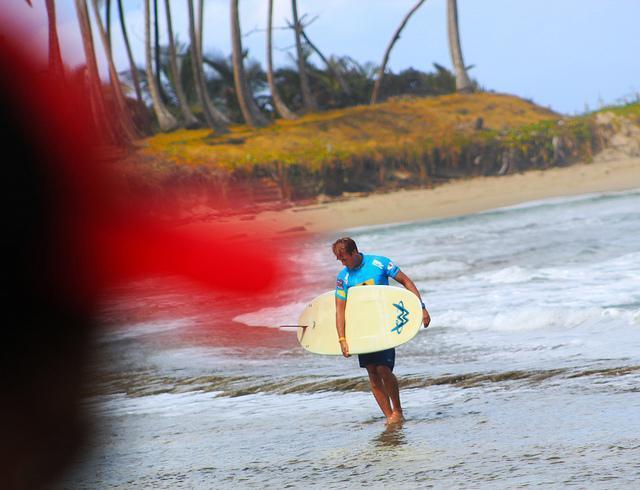How many people can you see?
Give a very brief answer. 2. How many orange boats are there?
Give a very brief answer. 0. 